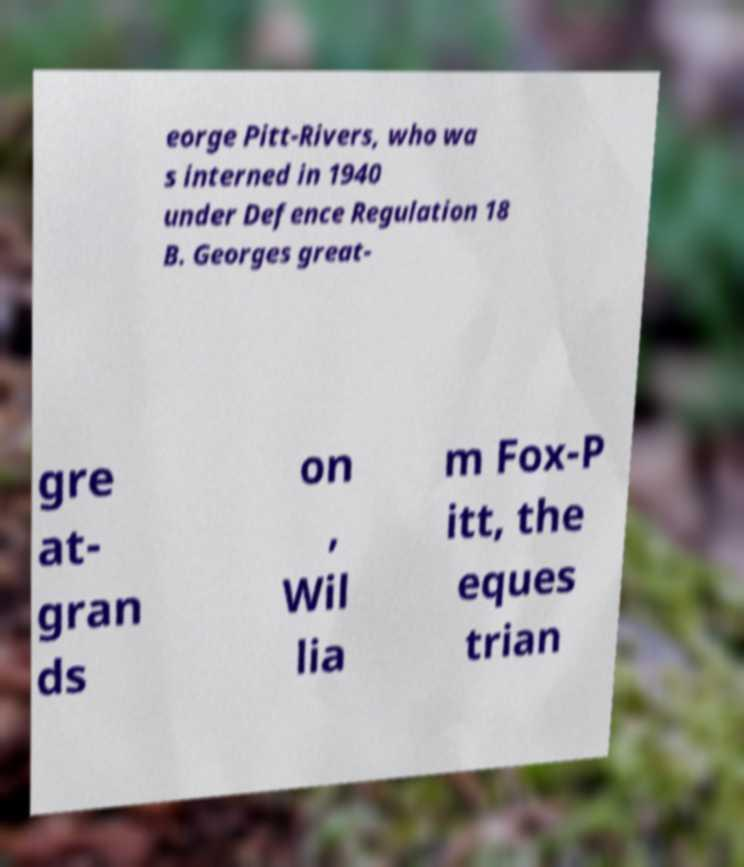Please identify and transcribe the text found in this image. eorge Pitt-Rivers, who wa s interned in 1940 under Defence Regulation 18 B. Georges great- gre at- gran ds on , Wil lia m Fox-P itt, the eques trian 